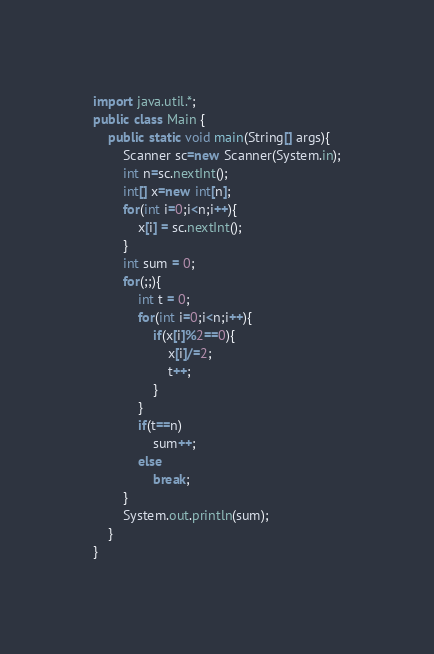<code> <loc_0><loc_0><loc_500><loc_500><_Java_>import java.util.*;
public class Main {
	public static void main(String[] args){
		Scanner sc=new Scanner(System.in);
		int n=sc.nextInt();
		int[] x=new int[n];
		for(int i=0;i<n;i++){
			x[i] = sc.nextInt();
		}
		int sum = 0;
		for(;;){
			int t = 0;
			for(int i=0;i<n;i++){
				if(x[i]%2==0){
					x[i]/=2;
					t++;
				}
			}
			if(t==n)
				sum++;
			else
				break;
		}
		System.out.println(sum);
	}
}
</code> 